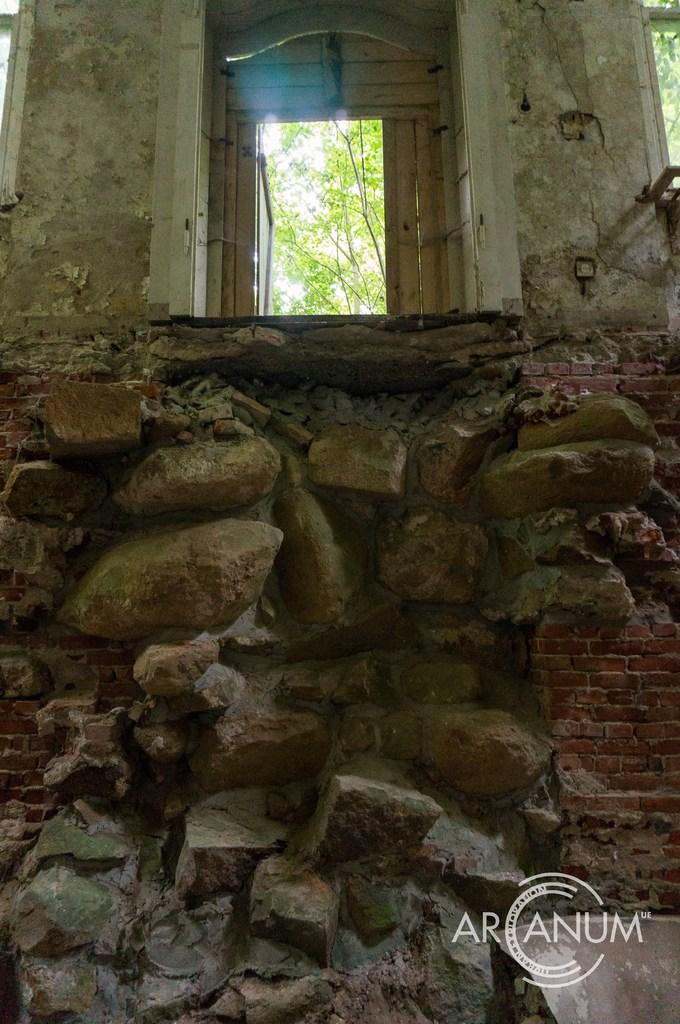What is the primary feature of the image? There are many rocks in the image. What is located above the rocks? There is a room above the rocks. What material is the room made of? The room is made up of cement. What can be seen outside the room? There are trees visible outside the room. What is visible in the background of the image? The sky is visible in the image. What type of activity is taking place in the library in the image? There is no library present in the image; it features rocks and a room made of cement. How many trees are visible in the image? The number of trees visible in the image cannot be determined from the provided facts. 